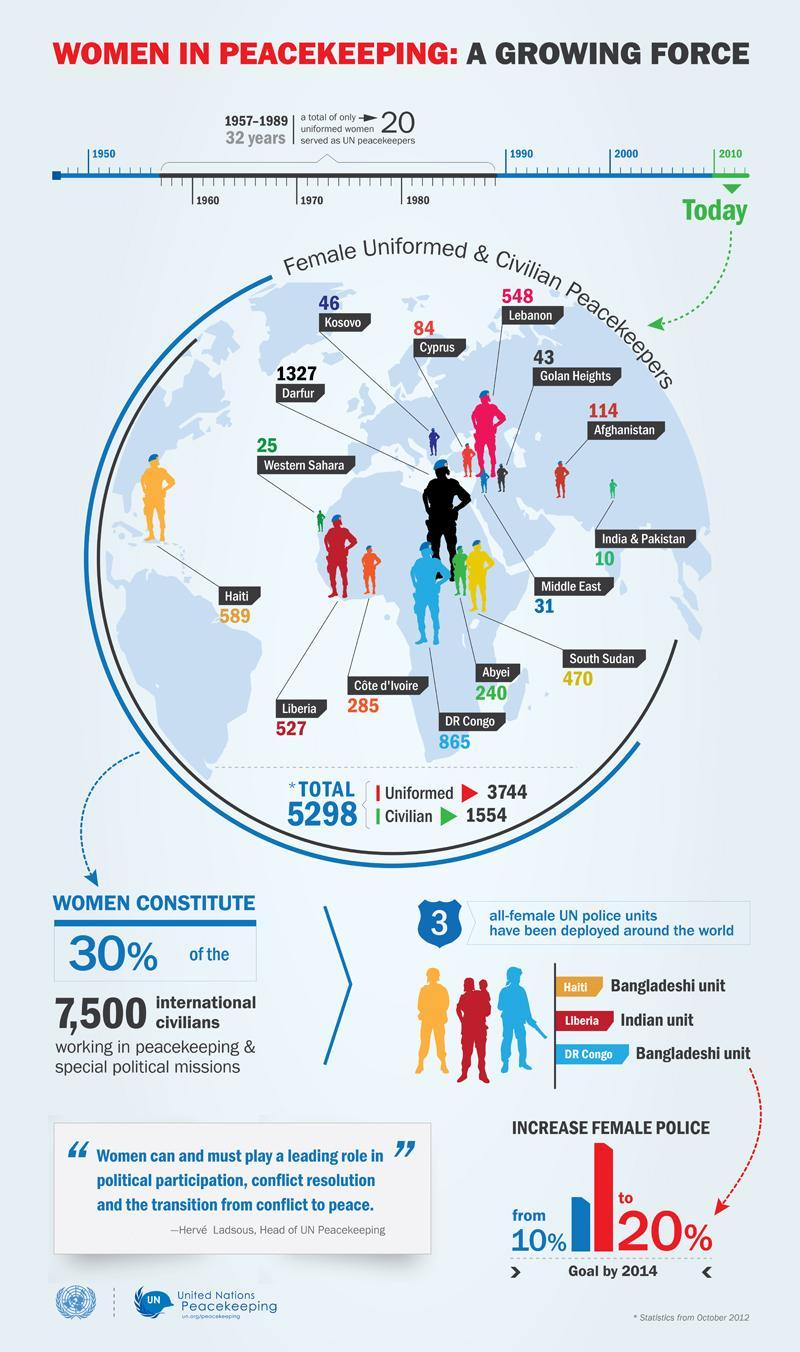What is the total count of female uniformed and civilian peacekeepers
Answer the question with a short phrase. 5298 What is the difference in % between the current % of female police to the planned % by 2014 10 what is the total count of female peace keeping force in Kosovo and Cyprus 130 what category of female peace keeping force is in Western Sahara Civilian what has been the increase in count of uniformed females in peace keeping force from 1990 to 2010 1534 Where is the Bangladeshi unit based DR Congo which place has the second highest count of female peace keeping force DR Congo 